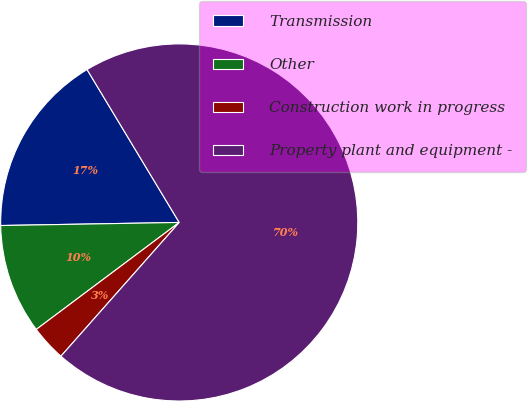<chart> <loc_0><loc_0><loc_500><loc_500><pie_chart><fcel>Transmission<fcel>Other<fcel>Construction work in progress<fcel>Property plant and equipment -<nl><fcel>16.64%<fcel>9.95%<fcel>3.25%<fcel>70.16%<nl></chart> 